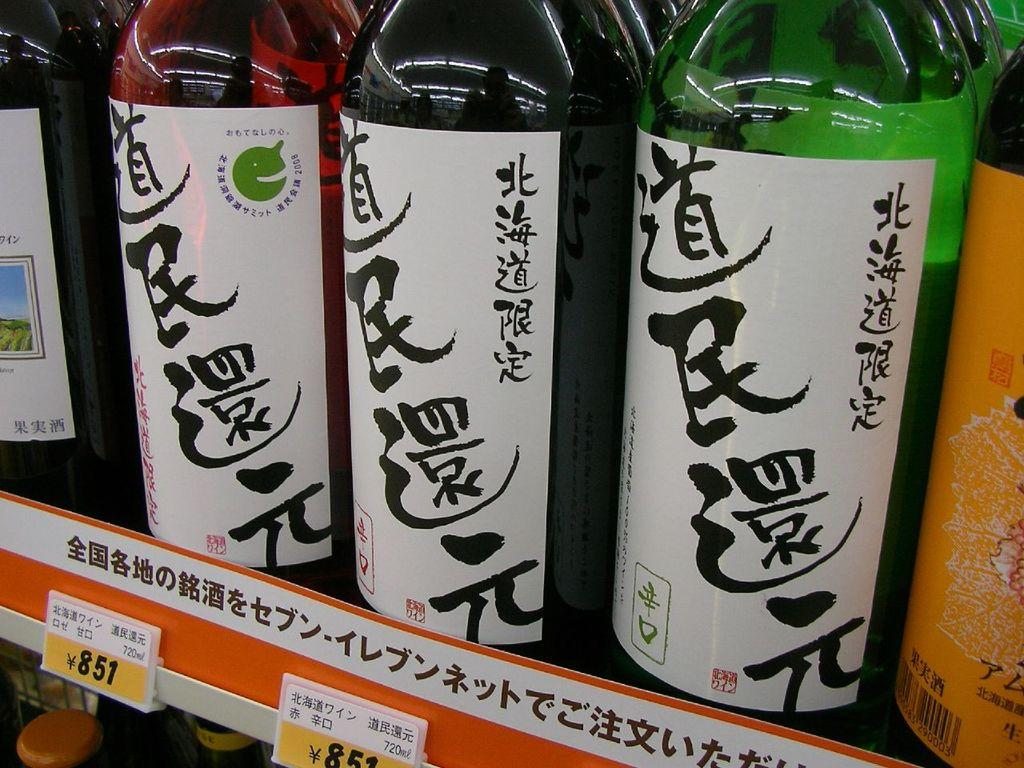Provide a one-sentence caption for the provided image. Three bottles with Chinese writing on it with a label underneath saying 851. 